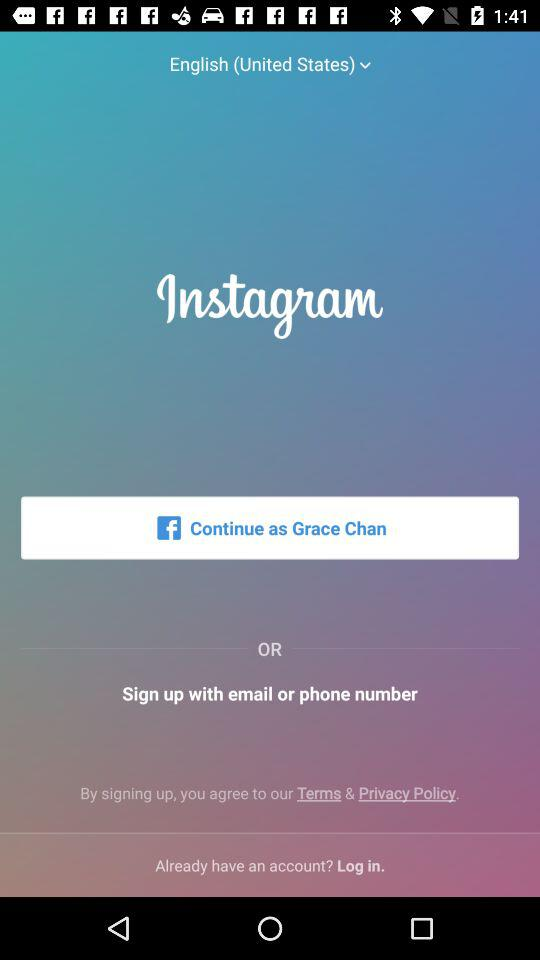Which language is selected? The selected language is English (United States). 